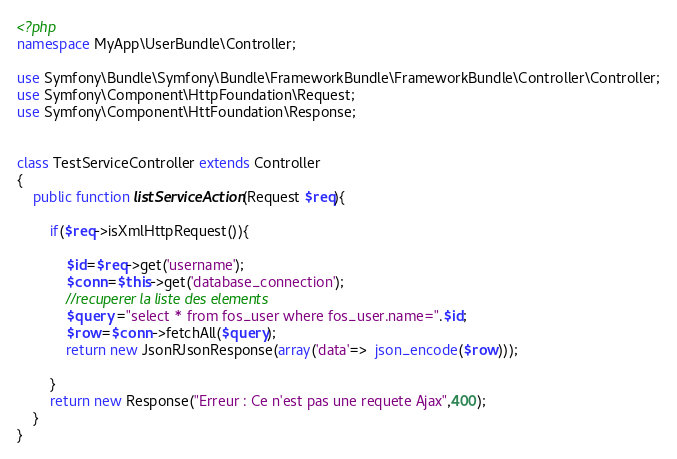<code> <loc_0><loc_0><loc_500><loc_500><_PHP_><?php
namespace MyApp\UserBundle\Controller;

use Symfony\Bundle\Symfony\Bundle\FrameworkBundle\FrameworkBundle\Controller\Controller;
use Symfony\Component\HttpFoundation\Request;
use Symfony\Component\HttFoundation\Response;


class TestServiceController extends Controller
{
    public function listServiceAction(Request $req){
        
        if($req->isXmlHttpRequest()){
            
            $id=$req->get('username');
            $conn=$this->get('database_connection');
            //recuperer la liste des elements
            $query ="select * from fos_user where fos_user.name=".$id;
            $row=$conn->fetchAll($query);
            return new JsonRJsonResponse(array('data'=>  json_encode($row)));
            
        }
        return new Response("Erreur : Ce n'est pas une requete Ajax",400);
    }
}

</code> 